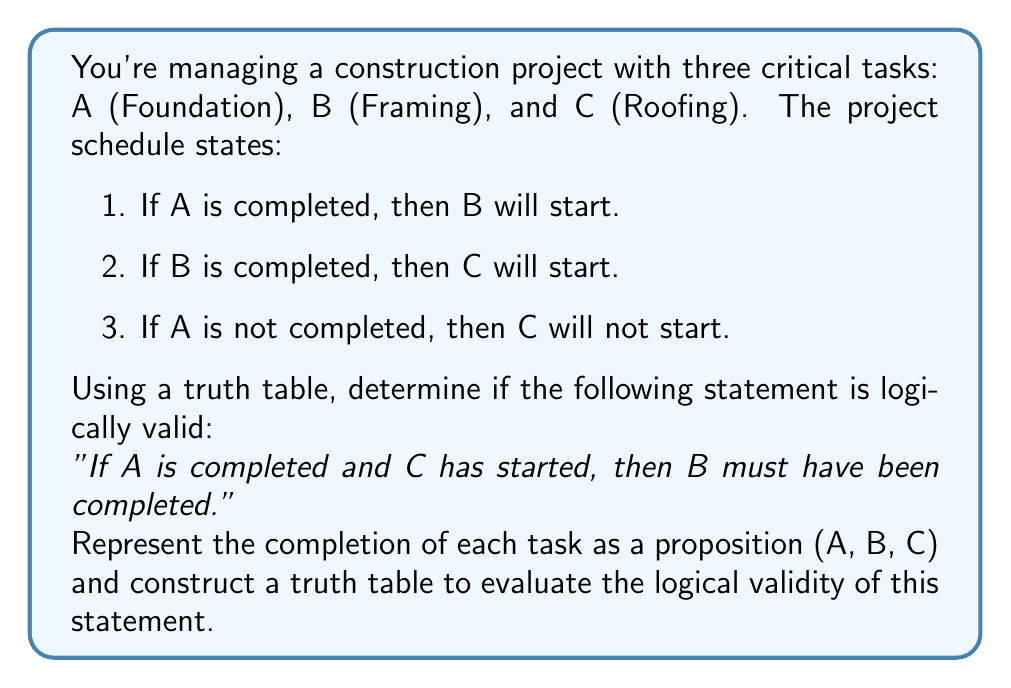Can you answer this question? Let's approach this step-by-step:

1. First, we need to translate the given statement into symbolic logic:
   $(A \land C) \rightarrow B$

2. We'll create a truth table with columns for A, B, C, $(A \land C)$, and $(A \land C) \rightarrow B$

3. The truth table:

   | A | B | C | $(A \land C)$ | $(A \land C) \rightarrow B$ |
   |---|---|---|----------------|------------------------------|
   | T | T | T |       T        |              T               |
   | T | T | F |       F        |              T               |
   | T | F | T |       T        |              F               |
   | T | F | F |       F        |              T               |
   | F | T | T |       F        |              T               |
   | F | T | F |       F        |              T               |
   | F | F | T |       F        |              T               |
   | F | F | F |       F        |              T               |

4. Analyzing the truth table:
   - The statement is logically valid if the last column is always true.
   - We see that there's one case where the result is false: when A is true, C is true, but B is false.

5. Interpreting the results:
   - This false case represents a situation where the foundation is completed (A is true) and the roofing has started (C is true), but the framing was not completed (B is false).
   - This situation contradicts the given project schedule rules, specifically rule 2: "If B is completed, then C will start."

6. However, the question asks about logical validity based solely on the given statement, not the additional project rules.

7. Since there exists a case where the implication is false (when the antecedent is true but the consequent is false), the statement is not logically valid according to the truth table.
Answer: The statement "If A is completed and C has started, then B must have been completed" is not logically valid based solely on the truth table analysis. There exists a case (A true, B false, C true) where the implication is false, even though this case contradicts the given project schedule rules. 